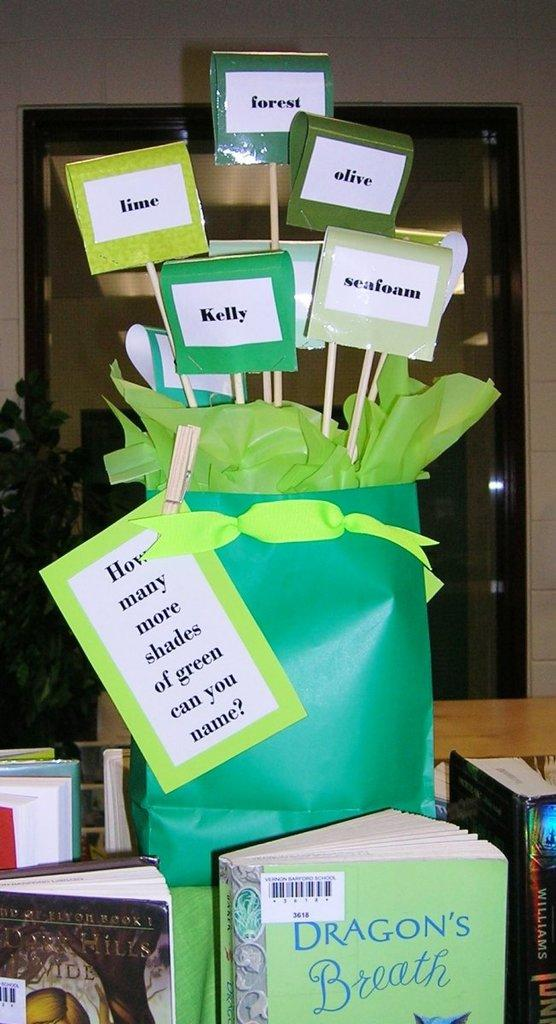Provide a one-sentence caption for the provided image. A green bag on a book display table. It says "how many shades of green can you name" and there's a signs with shades like lime, seafoam, kelly and olive. 